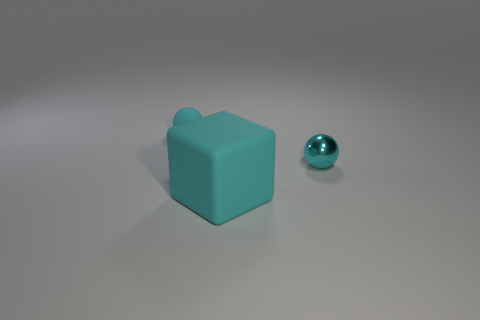Add 3 cyan blocks. How many objects exist? 6 Subtract all spheres. How many objects are left? 1 Subtract all large cyan rubber objects. Subtract all small things. How many objects are left? 0 Add 3 cyan things. How many cyan things are left? 6 Add 2 tiny cyan objects. How many tiny cyan objects exist? 4 Subtract 0 yellow spheres. How many objects are left? 3 